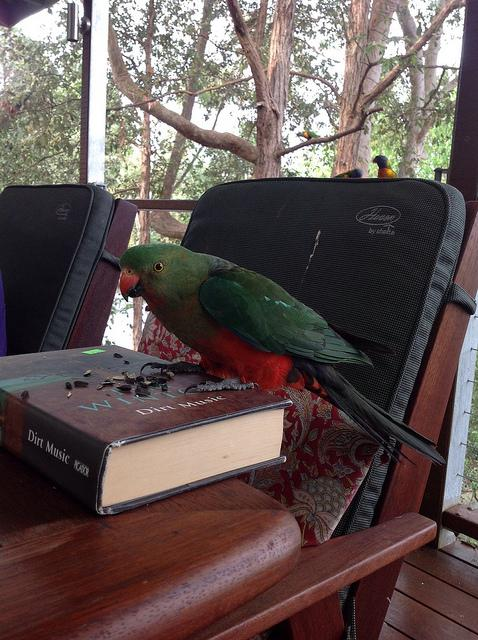What makes up the bulk of this bird's diet? Please explain your reasoning. fruits. The bird's diet is made of fruit. 